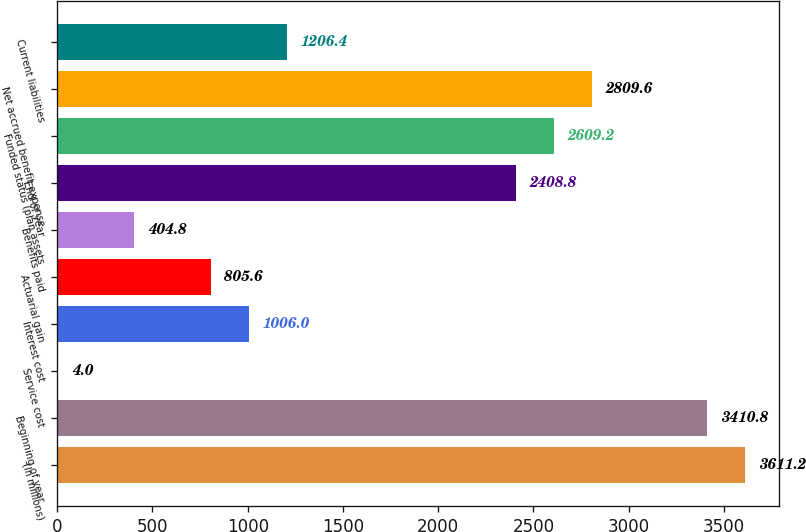Convert chart to OTSL. <chart><loc_0><loc_0><loc_500><loc_500><bar_chart><fcel>(In millions)<fcel>Beginning of year<fcel>Service cost<fcel>Interest cost<fcel>Actuarial gain<fcel>Benefits paid<fcel>End of year<fcel>Funded status (plan assets<fcel>Net accrued benefit expense<fcel>Current liabilities<nl><fcel>3611.2<fcel>3410.8<fcel>4<fcel>1006<fcel>805.6<fcel>404.8<fcel>2408.8<fcel>2609.2<fcel>2809.6<fcel>1206.4<nl></chart> 